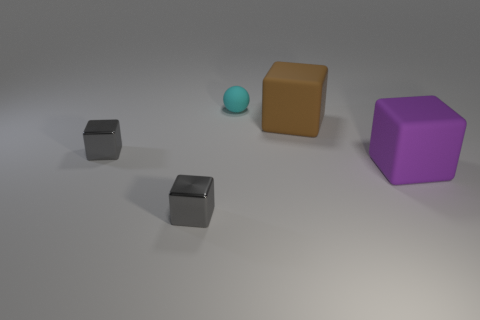Subtract all purple spheres. Subtract all blue cubes. How many spheres are left? 1 Subtract all yellow spheres. How many purple cubes are left? 1 Add 1 reds. How many big things exist? 0 Subtract all tiny matte things. Subtract all tiny blocks. How many objects are left? 2 Add 5 cyan things. How many cyan things are left? 6 Add 5 gray objects. How many gray objects exist? 7 Add 4 big blocks. How many objects exist? 9 Subtract all brown blocks. How many blocks are left? 3 Subtract all big brown cubes. How many cubes are left? 3 Subtract 0 purple cylinders. How many objects are left? 5 